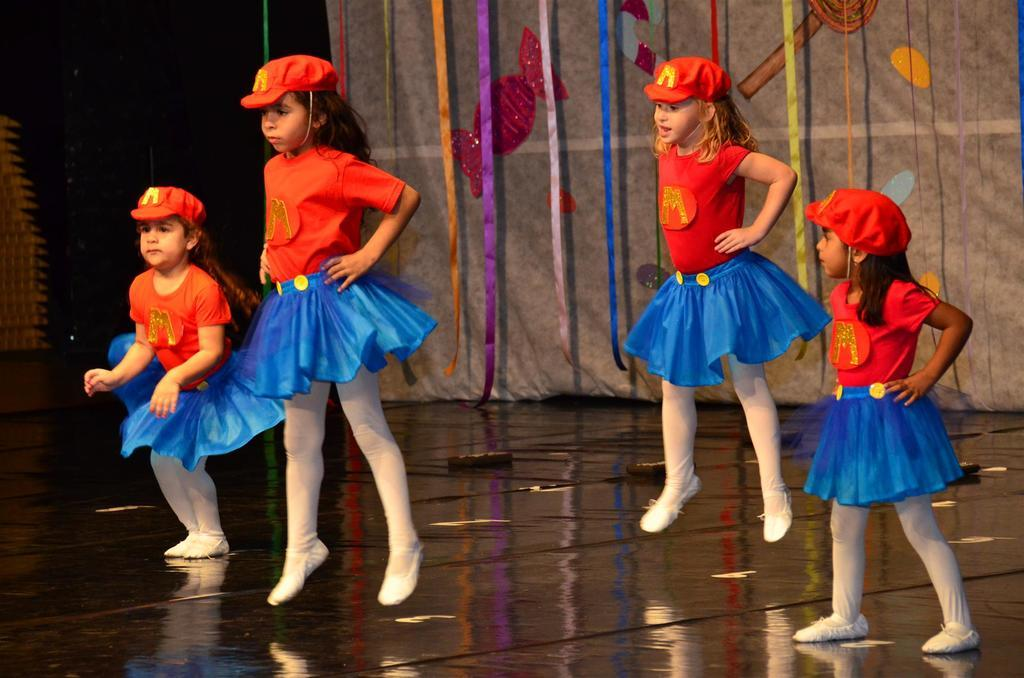What is the main subject of the image? The main subject of the image is a group of children. Where are the children located in the image? The children are standing on the ground. What can be seen in the background of the image? There is a group of ribbons in the background of the image. How many copies of the children's chins can be seen in the image? There are no copies of the children's chins in the image; each child has only one chin. 